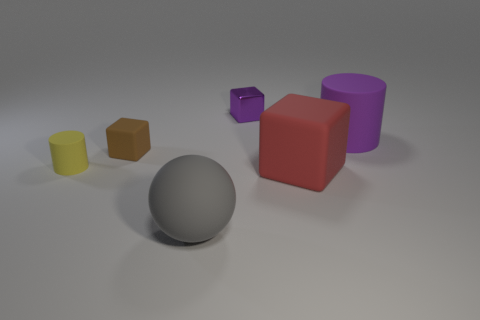Add 4 green metallic things. How many objects exist? 10 Subtract all brown blocks. How many blocks are left? 2 Subtract 2 cubes. How many cubes are left? 1 Subtract all cylinders. How many objects are left? 4 Subtract 0 green spheres. How many objects are left? 6 Subtract all red balls. Subtract all brown cylinders. How many balls are left? 1 Subtract all big purple matte cylinders. Subtract all red objects. How many objects are left? 4 Add 6 small rubber things. How many small rubber things are left? 8 Add 3 big blocks. How many big blocks exist? 4 Subtract all purple cylinders. How many cylinders are left? 1 